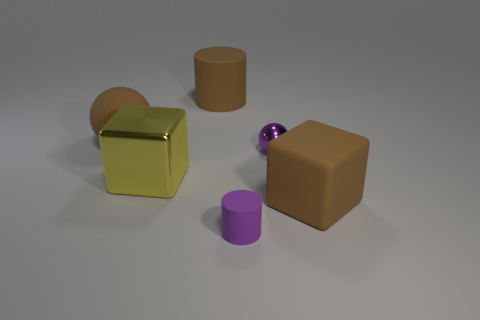Do the yellow object and the shiny sphere have the same size?
Offer a very short reply. No. How many cylinders have the same size as the yellow cube?
Offer a very short reply. 1. What shape is the small thing that is the same color as the small sphere?
Your answer should be compact. Cylinder. Do the brown object that is in front of the big rubber ball and the cube that is on the left side of the big cylinder have the same material?
Your answer should be compact. No. The large rubber cube has what color?
Offer a very short reply. Brown. What number of other rubber things have the same shape as the small rubber thing?
Make the answer very short. 1. The sphere that is the same size as the yellow block is what color?
Your answer should be compact. Brown. Are there any small blue blocks?
Provide a short and direct response. No. There is a large brown thing to the left of the large rubber cylinder; what is its shape?
Your response must be concise. Sphere. How many big matte objects are left of the small metal ball and in front of the matte sphere?
Your response must be concise. 0. 